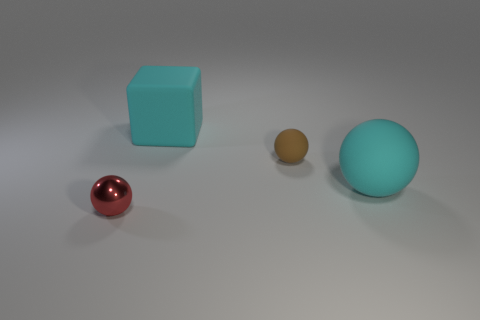Subtract all large rubber spheres. How many spheres are left? 2 Subtract 1 balls. How many balls are left? 2 Subtract all cyan balls. How many balls are left? 2 Add 1 blue shiny cylinders. How many objects exist? 5 Subtract all yellow spheres. Subtract all cyan cylinders. How many spheres are left? 3 Subtract all big purple shiny objects. Subtract all cyan things. How many objects are left? 2 Add 1 rubber spheres. How many rubber spheres are left? 3 Add 3 red objects. How many red objects exist? 4 Subtract 0 purple spheres. How many objects are left? 4 Subtract all balls. How many objects are left? 1 